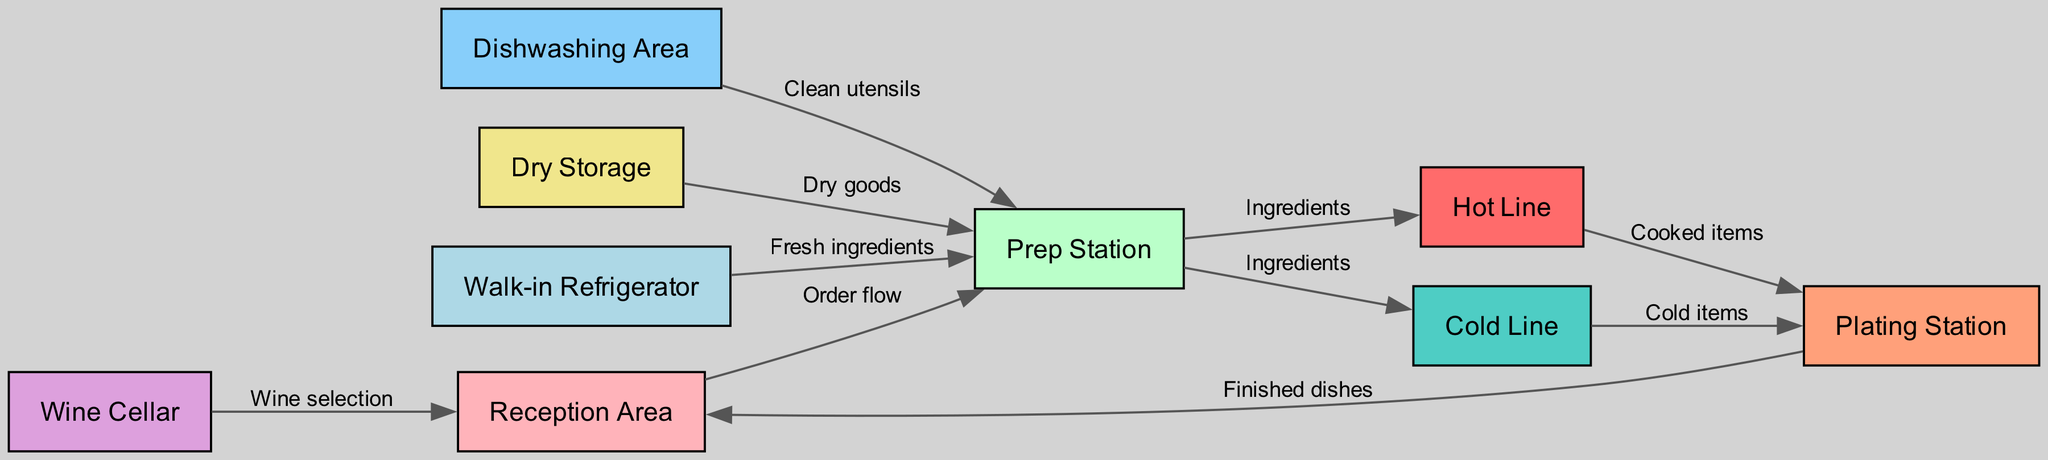What is the first node in the workflow? The first node in the workflow is the Reception Area, which is where orders are received before being sent to the prep station.
Answer: Reception Area How many nodes are there in total? By counting the unique locations in the diagram, I can identify that there are nine nodes, namely reception, prep, hot, cold, plating, dish, storage, fridge, and wine.
Answer: 9 What is the relationship between the Prep Station and the Hot Line? The relationship is that ingredients are sent from the Prep Station to the Hot Line, indicating a progression of workflow where ingredients are prepared before being cooked.
Answer: Ingredients How many different types of items are sent to the Plating Station? Between the Hot Line and the Cold Line, there are two types of items sent to the Plating Station: cooked items from the Hot Line and cold items from the Cold Line.
Answer: 2 What flow occurs from the Wine Cellar to Reception Area? The flow from the Wine Cellar to the Reception Area is the selection of wine, which suggests that wine choices are made in relation to the dining orders.
Answer: Wine selection Which station provides clean utensils back to the Prep Station? The Dishwashing Area is responsible for sending clean utensils back to the Prep Station, indicating a closed-loop for tool cleanliness during food preparation.
Answer: Clean utensils What type of ingredients does the Walk-in Refrigerator supply? The Walk-in Refrigerator supplies fresh ingredients to the Prep Station, which complements the workflow by ensuring that ingredients are fresh for food preparation.
Answer: Fresh ingredients What connects the Plating Station back to the Reception Area? Finished dishes are sent from the Plating Station back to the Reception Area, completing the cycle of service from preparation to the final delivery to customers.
Answer: Finished dishes What is the main purpose of the Storage area? The main purpose of the Storage area is to provide dry goods to the Prep Station, adding essential ingredients that don’t require refrigeration in the cooking process.
Answer: Dry goods 